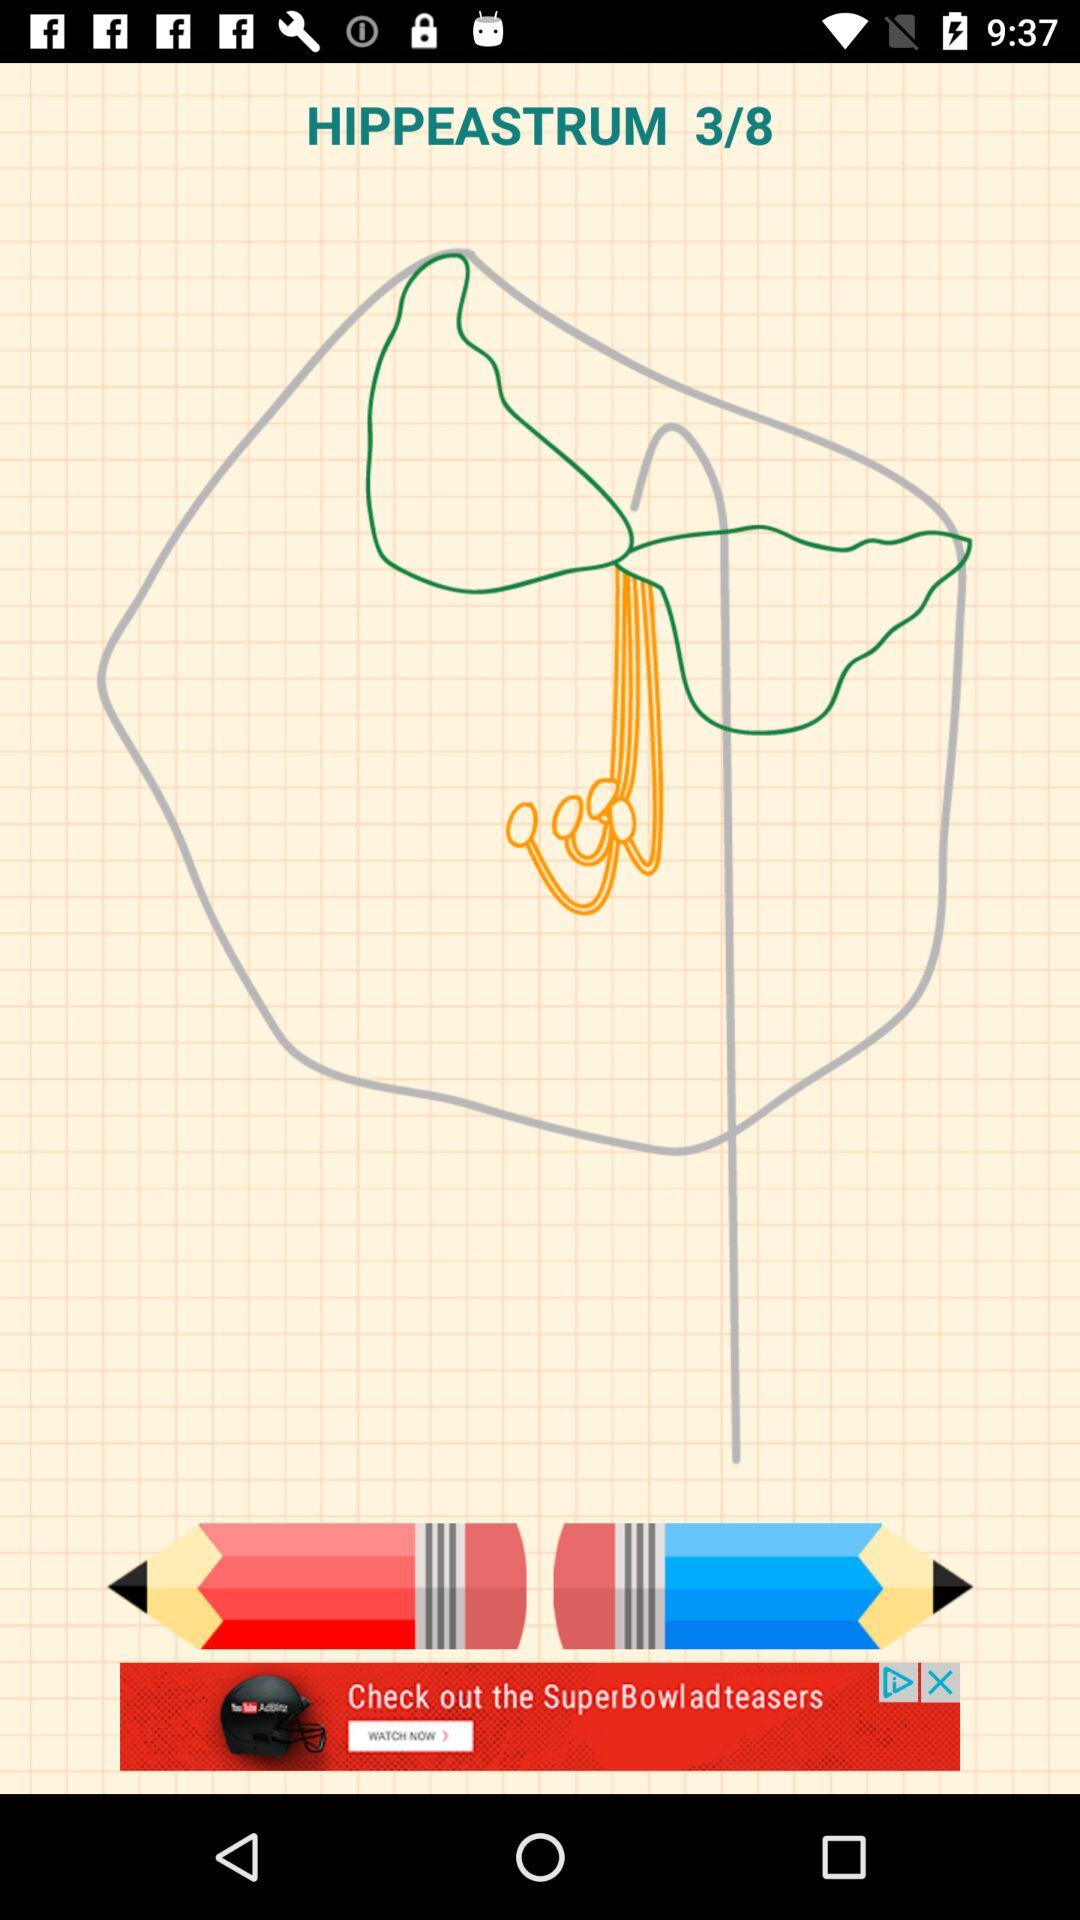How many pencils have a black stripe?
Answer the question using a single word or phrase. 2 